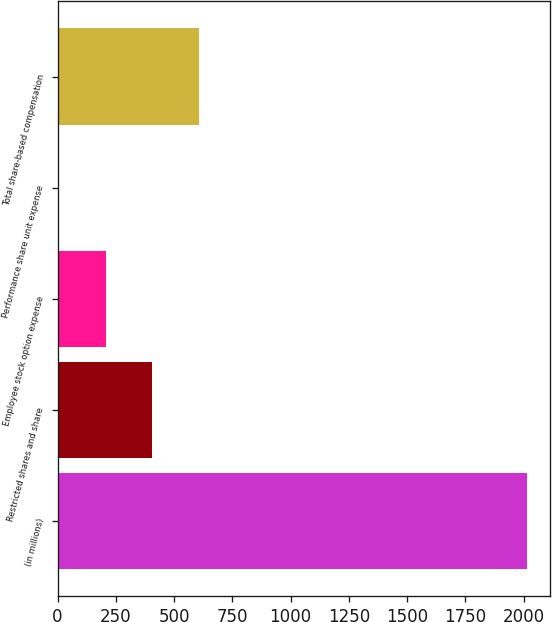Convert chart. <chart><loc_0><loc_0><loc_500><loc_500><bar_chart><fcel>(in millions)<fcel>Restricted shares and share<fcel>Employee stock option expense<fcel>Performance share unit expense<fcel>Total share-based compensation<nl><fcel>2012<fcel>407.2<fcel>206.6<fcel>6<fcel>607.8<nl></chart> 